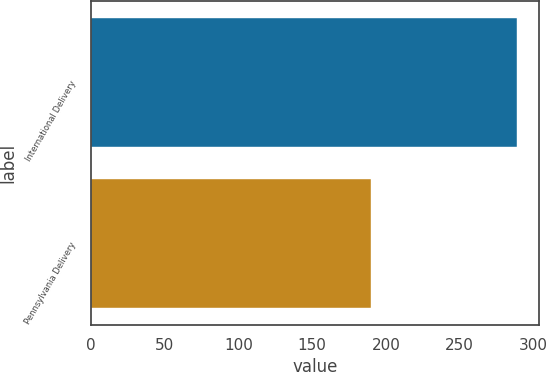<chart> <loc_0><loc_0><loc_500><loc_500><bar_chart><fcel>International Delivery<fcel>Pennsylvania Delivery<nl><fcel>289<fcel>190<nl></chart> 